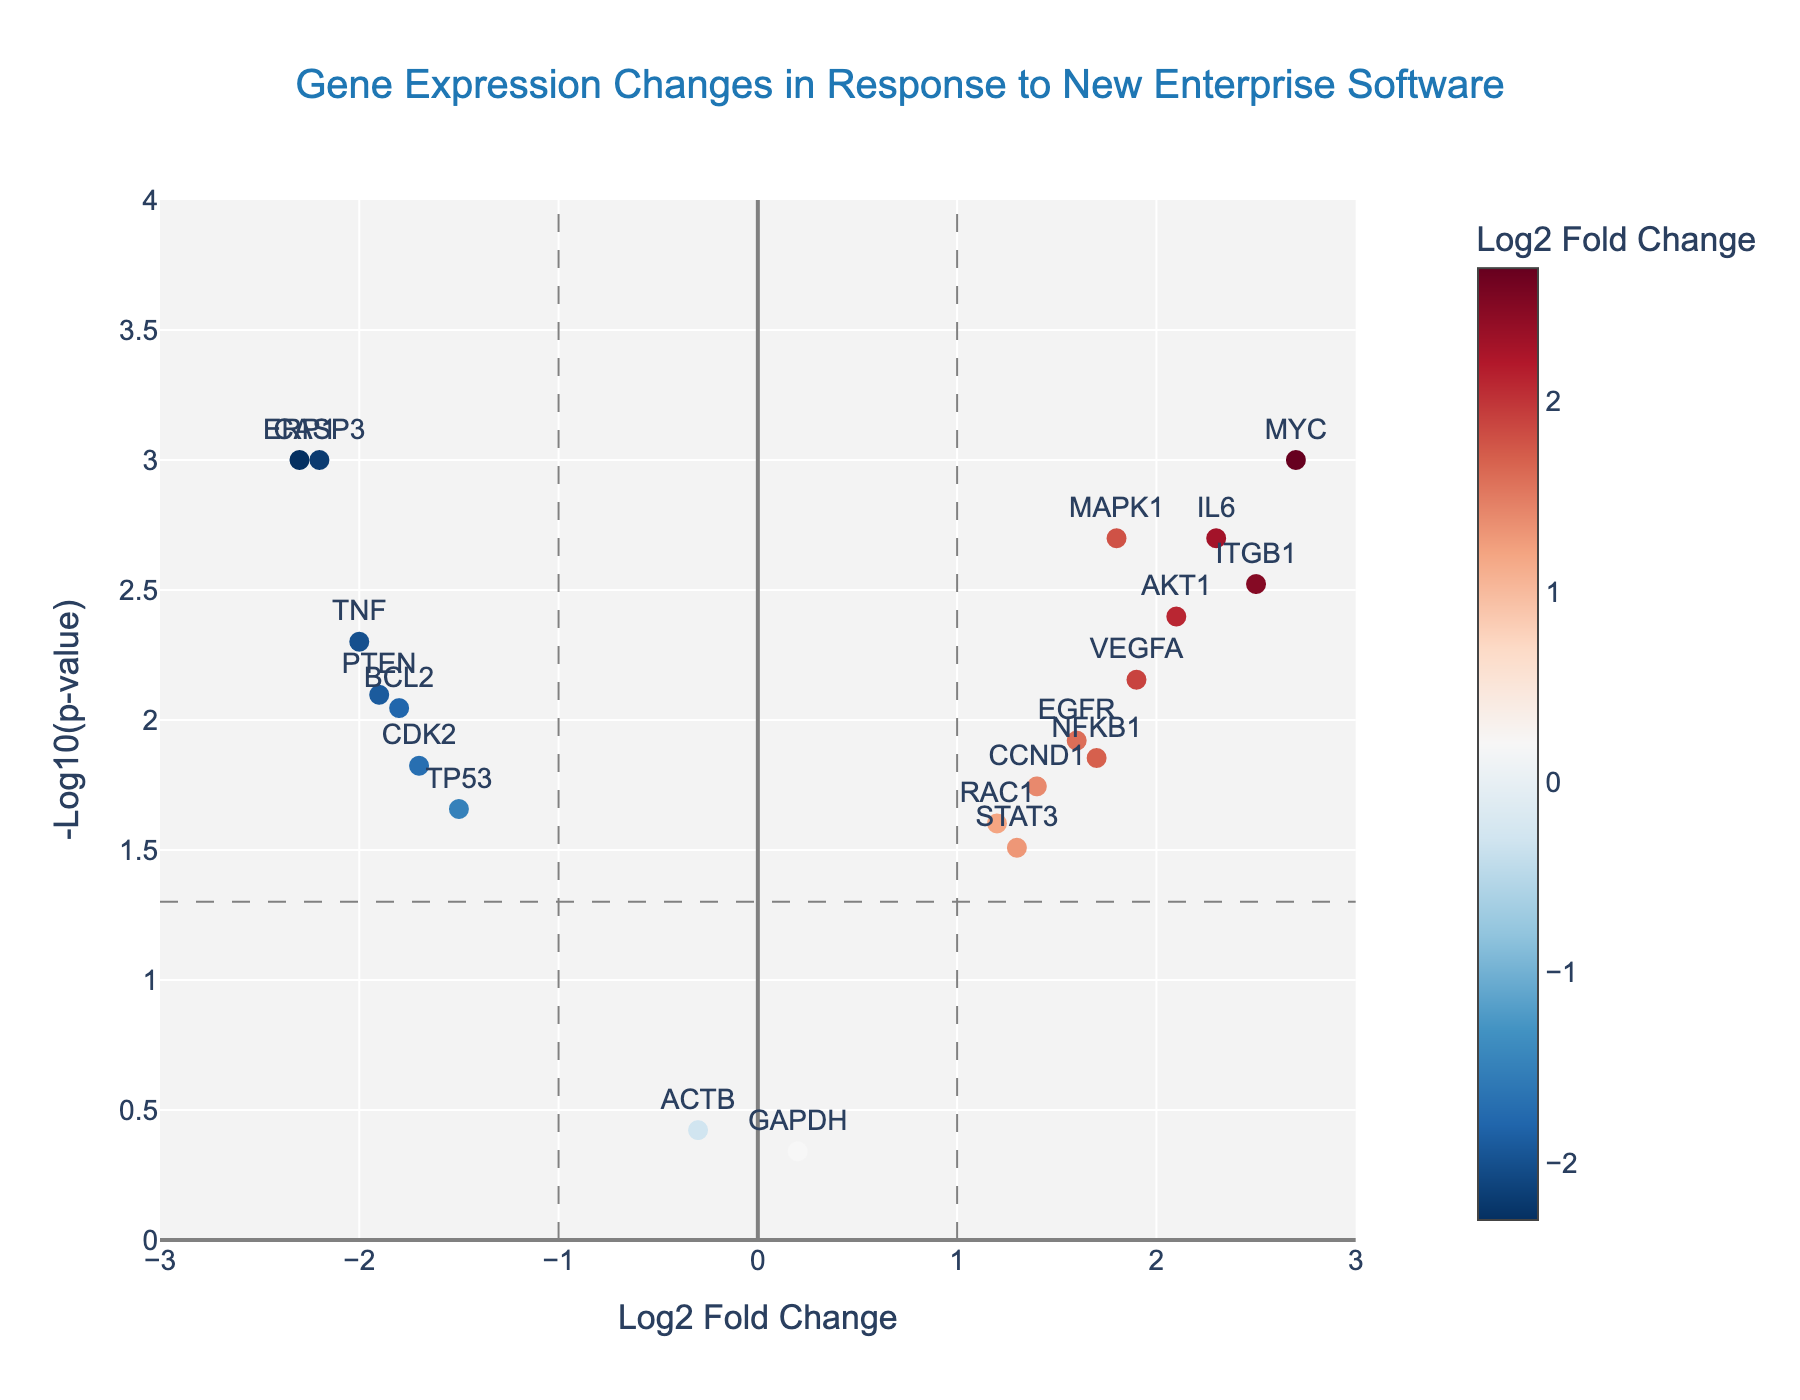What is the title of the plot? The title is located at the top of the plot, which describes its main purpose.
Answer: Gene Expression Changes in Response to New Enterprise Software How many genes are significantly up-regulated? Significantly up-regulated genes are those with log2 fold change >1 and -log10(p-value) > -log10(0.05). Count the number of such points.
Answer: 7 Which gene has the highest log2 fold change? Identify the gene with the maximum value on the x-axis.
Answer: MYC What is the significance threshold represented by the horizontal line? The horizontal dashed line represents -log10(0.05), which is the significance threshold.
Answer: 1.3 How many genes have a p-value less than 0.01? Count the number of genes with -log10(p-value) > 2 (-log10(0.01) = 2).
Answer: 9 What color represents the highest log2 fold changes, and which genes are in this category? The color scale shows higher fold changes in red. Identify the red points and their corresponding genes.
Answer: MYC, ITGB1, IL6, AKT1 Which gene is the most down-regulated? Look for the gene with the minimum log2 fold change on the negative side of the x-axis.
Answer: ERP1 Compare the log2 fold changes of MAPK1 and NFKB1. Which one is higher? Find the log2 fold change values of MAPK1 and NFKB1 and compare them directly.
Answer: MAPK1 How many genes fall within the non-significant range of p-value > 0.05? Non-significant genes have -log10(p-value) < 1.3. Count these points.
Answer: 2 Which up-regulated gene has the smallest p-value? Among the up-regulated genes (positive log2 fold change), identify the one with the highest -log10(p-value).
Answer: MYC 